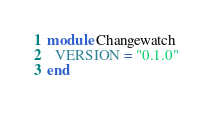Convert code to text. <code><loc_0><loc_0><loc_500><loc_500><_Ruby_>module Changewatch
  VERSION = "0.1.0"
end
</code> 